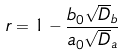Convert formula to latex. <formula><loc_0><loc_0><loc_500><loc_500>r = 1 - \frac { b _ { 0 } \sqrt { D } _ { b } } { a _ { 0 } \sqrt { D } _ { a } }</formula> 